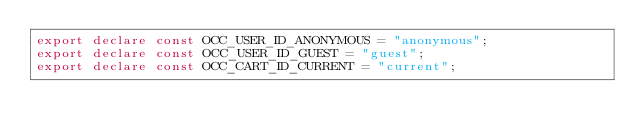Convert code to text. <code><loc_0><loc_0><loc_500><loc_500><_TypeScript_>export declare const OCC_USER_ID_ANONYMOUS = "anonymous";
export declare const OCC_USER_ID_GUEST = "guest";
export declare const OCC_CART_ID_CURRENT = "current";
</code> 